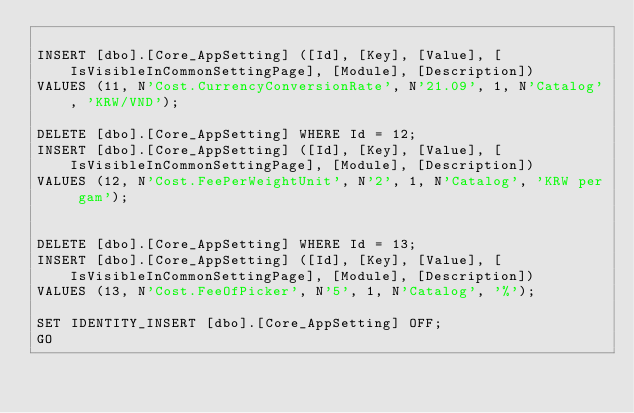Convert code to text. <code><loc_0><loc_0><loc_500><loc_500><_SQL_>
INSERT [dbo].[Core_AppSetting] ([Id], [Key], [Value], [IsVisibleInCommonSettingPage], [Module], [Description]) 
VALUES (11, N'Cost.CurrencyConversionRate', N'21.09', 1, N'Catalog', 'KRW/VND');

DELETE [dbo].[Core_AppSetting] WHERE Id = 12;
INSERT [dbo].[Core_AppSetting] ([Id], [Key], [Value], [IsVisibleInCommonSettingPage], [Module], [Description]) 
VALUES (12, N'Cost.FeePerWeightUnit', N'2', 1, N'Catalog', 'KRW per gam');


DELETE [dbo].[Core_AppSetting] WHERE Id = 13;
INSERT [dbo].[Core_AppSetting] ([Id], [Key], [Value], [IsVisibleInCommonSettingPage], [Module], [Description]) 
VALUES (13, N'Cost.FeeOfPicker', N'5', 1, N'Catalog', '%');

SET IDENTITY_INSERT [dbo].[Core_AppSetting] OFF;
GO</code> 